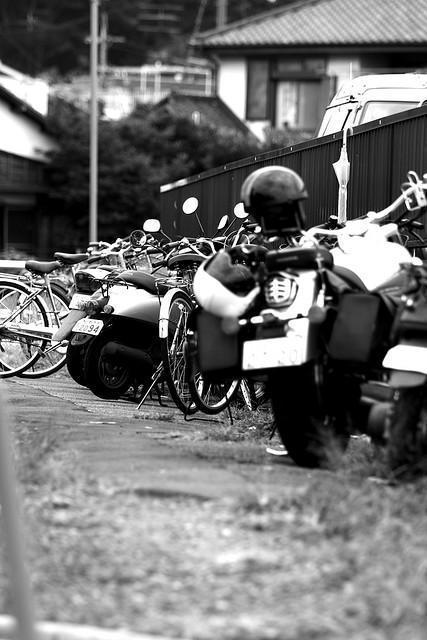How many helmets do you see?
Give a very brief answer. 2. How many bicycles are there?
Give a very brief answer. 3. How many motorcycles are visible?
Give a very brief answer. 4. How many trains are there?
Give a very brief answer. 0. 